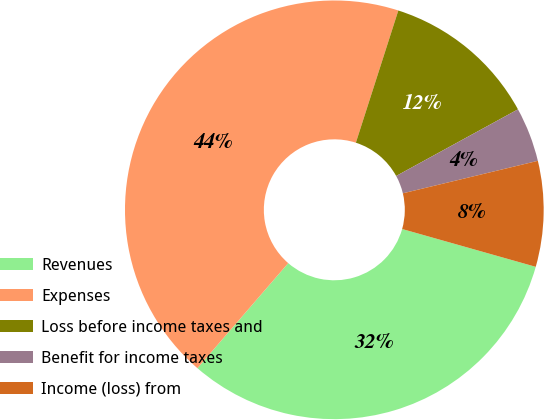Convert chart to OTSL. <chart><loc_0><loc_0><loc_500><loc_500><pie_chart><fcel>Revenues<fcel>Expenses<fcel>Loss before income taxes and<fcel>Benefit for income taxes<fcel>Income (loss) from<nl><fcel>31.96%<fcel>43.61%<fcel>12.09%<fcel>4.21%<fcel>8.15%<nl></chart> 